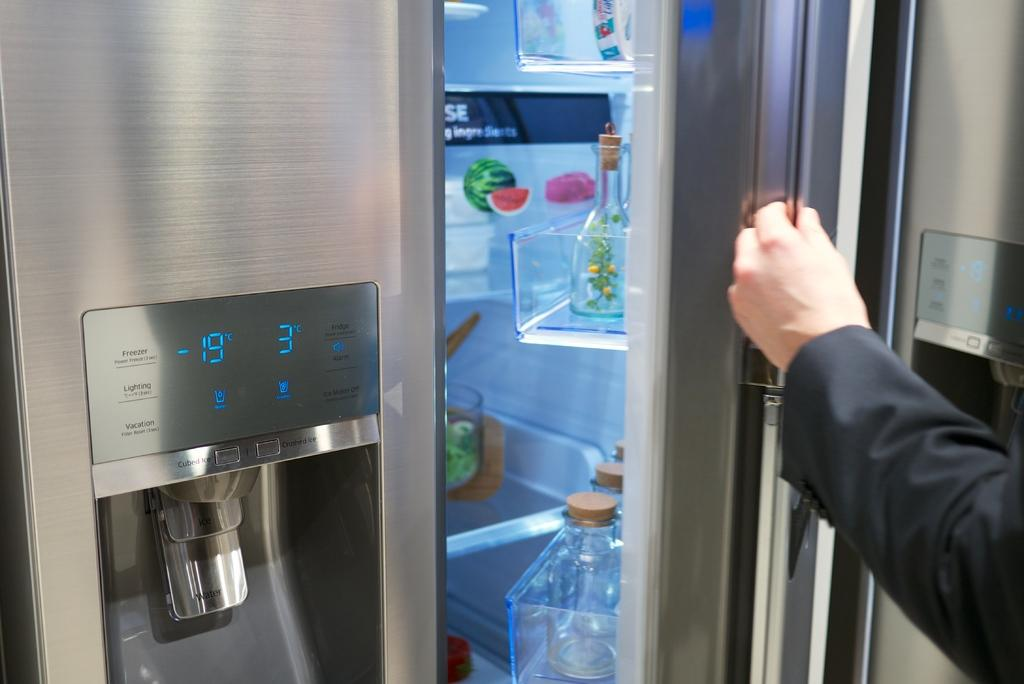<image>
Give a short and clear explanation of the subsequent image. A side by side refrigerator in stainless steel with a digital display of 3 degrees and -19 degrees. 